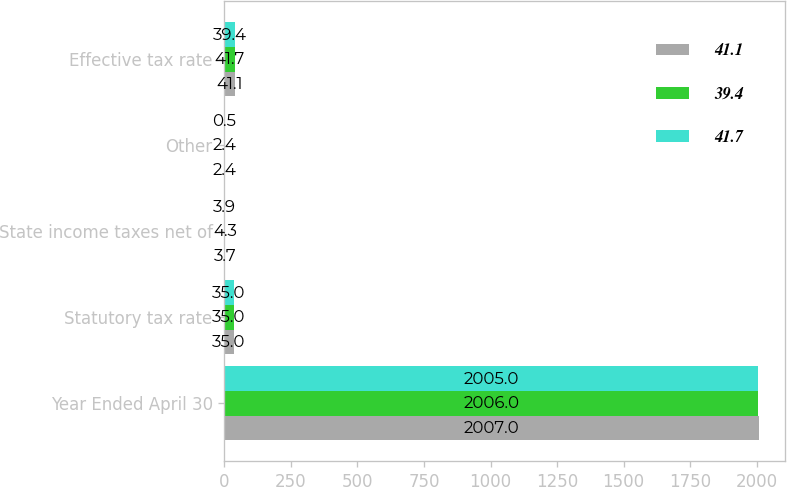Convert chart. <chart><loc_0><loc_0><loc_500><loc_500><stacked_bar_chart><ecel><fcel>Year Ended April 30<fcel>Statutory tax rate<fcel>State income taxes net of<fcel>Other<fcel>Effective tax rate<nl><fcel>41.1<fcel>2007<fcel>35<fcel>3.7<fcel>2.4<fcel>41.1<nl><fcel>39.4<fcel>2006<fcel>35<fcel>4.3<fcel>2.4<fcel>41.7<nl><fcel>41.7<fcel>2005<fcel>35<fcel>3.9<fcel>0.5<fcel>39.4<nl></chart> 